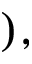<formula> <loc_0><loc_0><loc_500><loc_500>) ,</formula> 